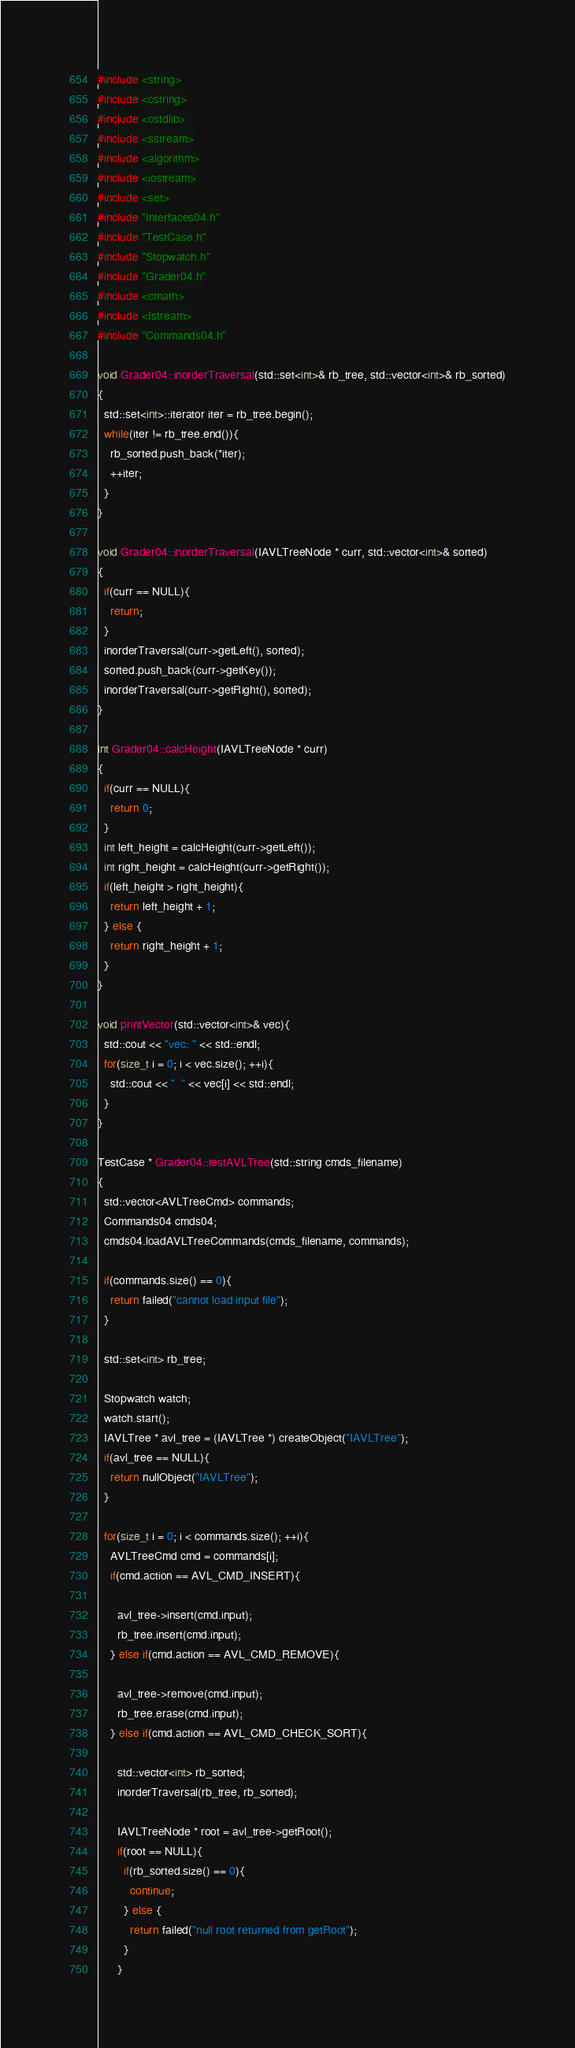Convert code to text. <code><loc_0><loc_0><loc_500><loc_500><_C++_>#include <string>
#include <cstring>
#include <cstdlib>
#include <sstream>
#include <algorithm>
#include <iostream>
#include <set>
#include "Interfaces04.h"
#include "TestCase.h"
#include "Stopwatch.h"
#include "Grader04.h"
#include <cmath>
#include <fstream>
#include "Commands04.h" 

void Grader04::inorderTraversal(std::set<int>& rb_tree, std::vector<int>& rb_sorted)
{
  std::set<int>::iterator iter = rb_tree.begin();
  while(iter != rb_tree.end()){
    rb_sorted.push_back(*iter);
    ++iter;
  }
}

void Grader04::inorderTraversal(IAVLTreeNode * curr, std::vector<int>& sorted)
{
  if(curr == NULL){
    return;
  }
  inorderTraversal(curr->getLeft(), sorted);
  sorted.push_back(curr->getKey());
  inorderTraversal(curr->getRight(), sorted);
}
  
int Grader04::calcHeight(IAVLTreeNode * curr)
{
  if(curr == NULL){
    return 0;
  }
  int left_height = calcHeight(curr->getLeft());
  int right_height = calcHeight(curr->getRight());
  if(left_height > right_height){
    return left_height + 1;
  } else {
    return right_height + 1;
  }
}

void printVector(std::vector<int>& vec){
  std::cout << "vec: " << std::endl;
  for(size_t i = 0; i < vec.size(); ++i){
    std::cout << "  " << vec[i] << std::endl;
  }
}

TestCase * Grader04::testAVLTree(std::string cmds_filename)
{
  std::vector<AVLTreeCmd> commands;
  Commands04 cmds04;
  cmds04.loadAVLTreeCommands(cmds_filename, commands);

  if(commands.size() == 0){
    return failed("cannot load input file");
  }

  std::set<int> rb_tree;

  Stopwatch watch;
  watch.start();
  IAVLTree * avl_tree = (IAVLTree *) createObject("IAVLTree");
  if(avl_tree == NULL){
    return nullObject("IAVLTree");
  }
  
  for(size_t i = 0; i < commands.size(); ++i){
    AVLTreeCmd cmd = commands[i];
    if(cmd.action == AVL_CMD_INSERT){
      
      avl_tree->insert(cmd.input);
      rb_tree.insert(cmd.input);
    } else if(cmd.action == AVL_CMD_REMOVE){
      
      avl_tree->remove(cmd.input);
      rb_tree.erase(cmd.input);
    } else if(cmd.action == AVL_CMD_CHECK_SORT){
      
      std::vector<int> rb_sorted;
      inorderTraversal(rb_tree, rb_sorted);

      IAVLTreeNode * root = avl_tree->getRoot();
      if(root == NULL){
        if(rb_sorted.size() == 0){
          continue;
        } else {
          return failed("null root returned from getRoot");
        }
      }</code> 